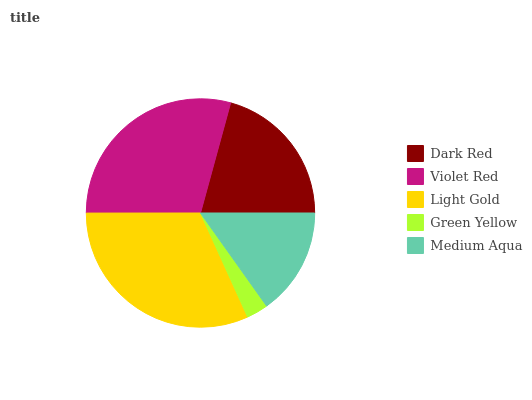Is Green Yellow the minimum?
Answer yes or no. Yes. Is Light Gold the maximum?
Answer yes or no. Yes. Is Violet Red the minimum?
Answer yes or no. No. Is Violet Red the maximum?
Answer yes or no. No. Is Violet Red greater than Dark Red?
Answer yes or no. Yes. Is Dark Red less than Violet Red?
Answer yes or no. Yes. Is Dark Red greater than Violet Red?
Answer yes or no. No. Is Violet Red less than Dark Red?
Answer yes or no. No. Is Dark Red the high median?
Answer yes or no. Yes. Is Dark Red the low median?
Answer yes or no. Yes. Is Green Yellow the high median?
Answer yes or no. No. Is Medium Aqua the low median?
Answer yes or no. No. 